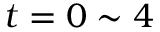Convert formula to latex. <formula><loc_0><loc_0><loc_500><loc_500>t = 0 \sim 4</formula> 